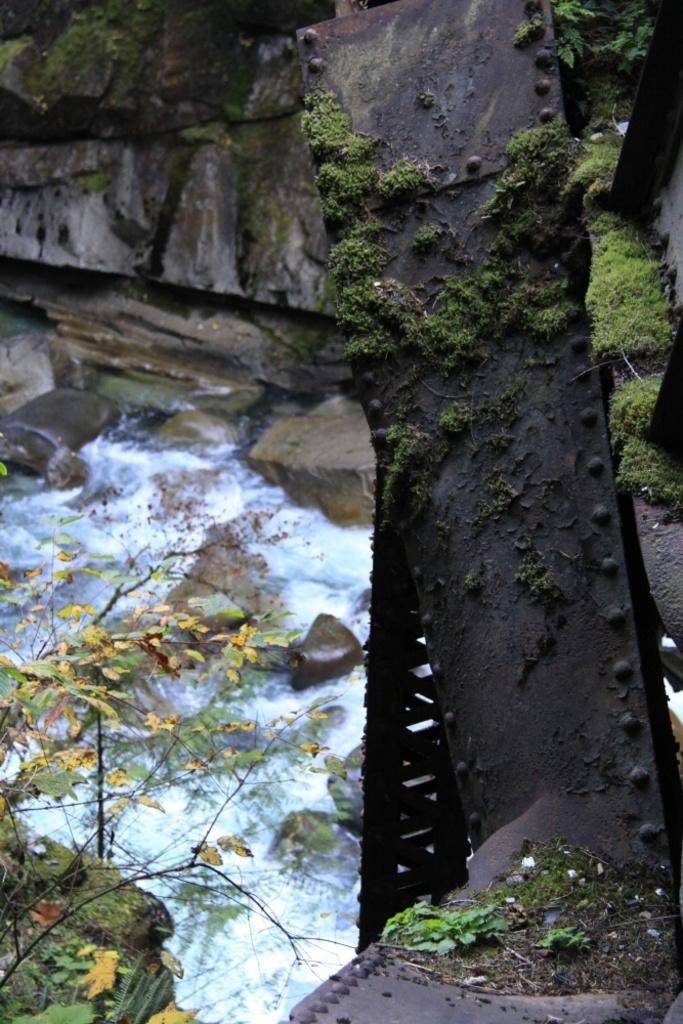Could you give a brief overview of what you see in this image? This image consists of a stand made up of metal. At the bottom, there is water flowing. In the background, there are rocks. At the bottom left, there is a plant. 